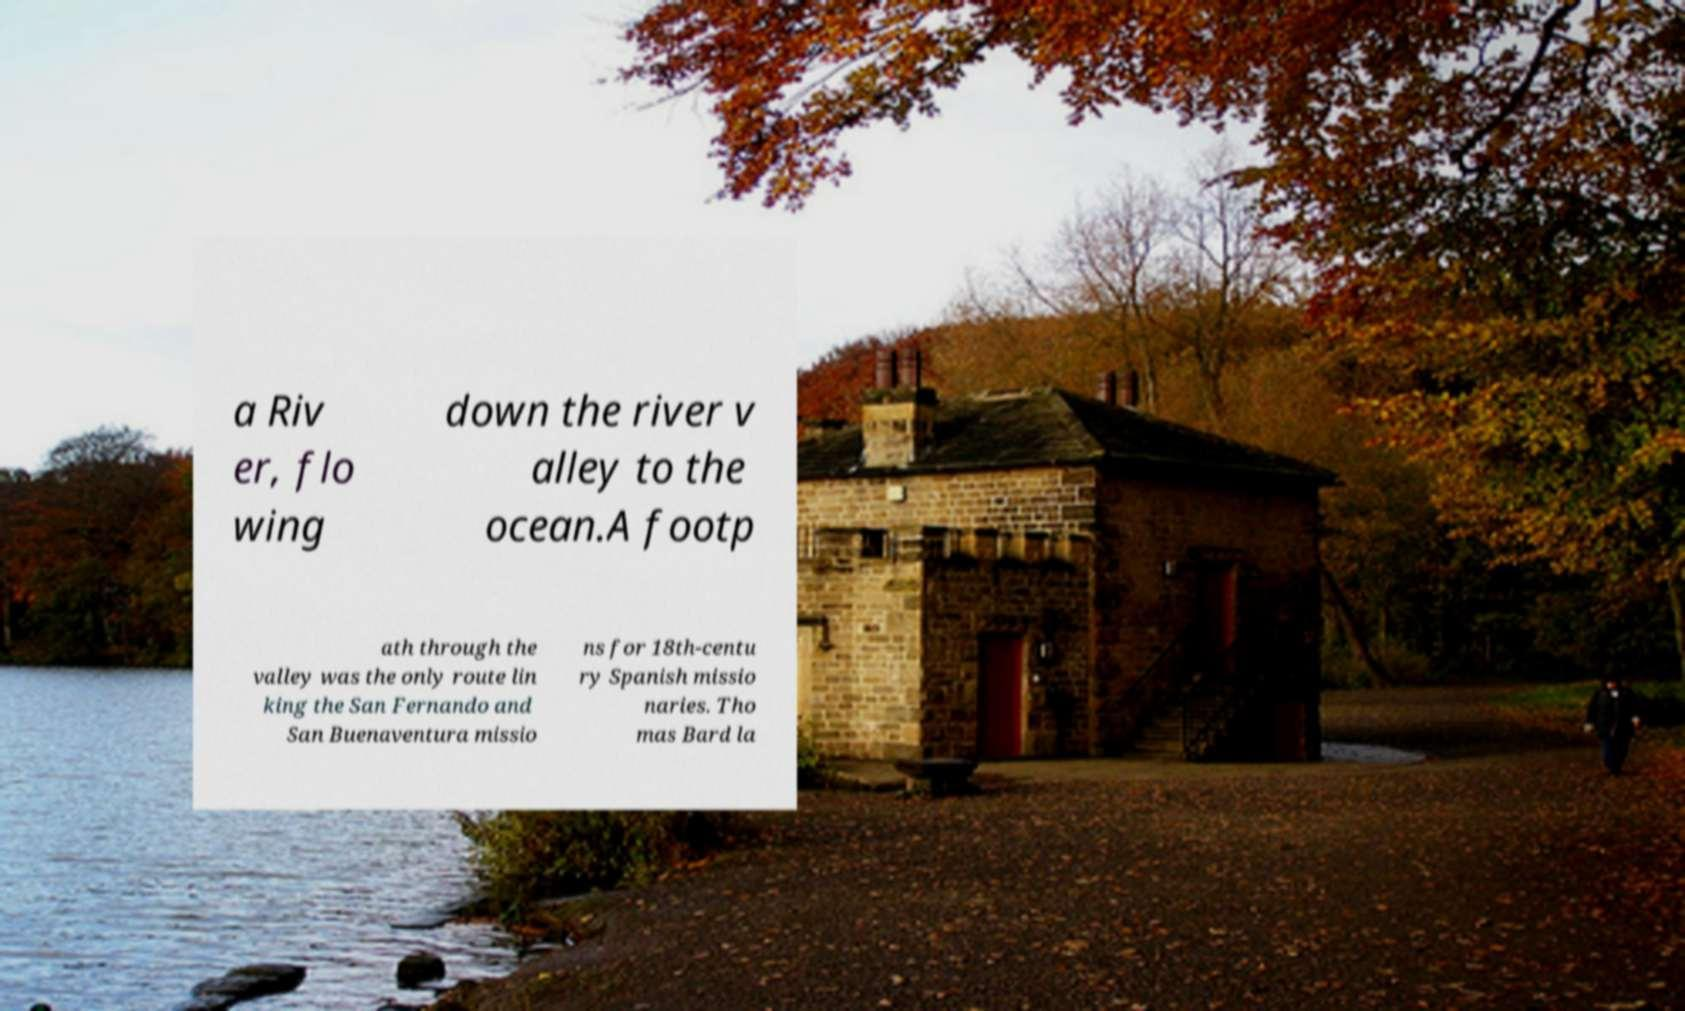What messages or text are displayed in this image? I need them in a readable, typed format. a Riv er, flo wing down the river v alley to the ocean.A footp ath through the valley was the only route lin king the San Fernando and San Buenaventura missio ns for 18th-centu ry Spanish missio naries. Tho mas Bard la 